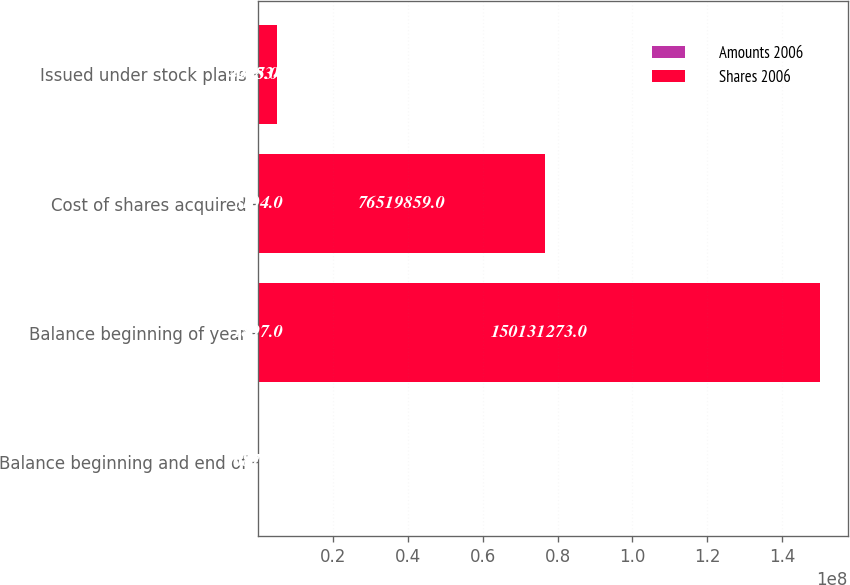Convert chart to OTSL. <chart><loc_0><loc_0><loc_500><loc_500><stacked_bar_chart><ecel><fcel>Balance beginning and end of<fcel>Balance beginning of year<fcel>Cost of shares acquired<fcel>Issued under stock plans<nl><fcel>Amounts 2006<fcel>6878<fcel>1897<fcel>5104<fcel>305<nl><fcel>Shares 2006<fcel>6878<fcel>1.50131e+08<fcel>7.65199e+07<fcel>4.95834e+06<nl></chart> 